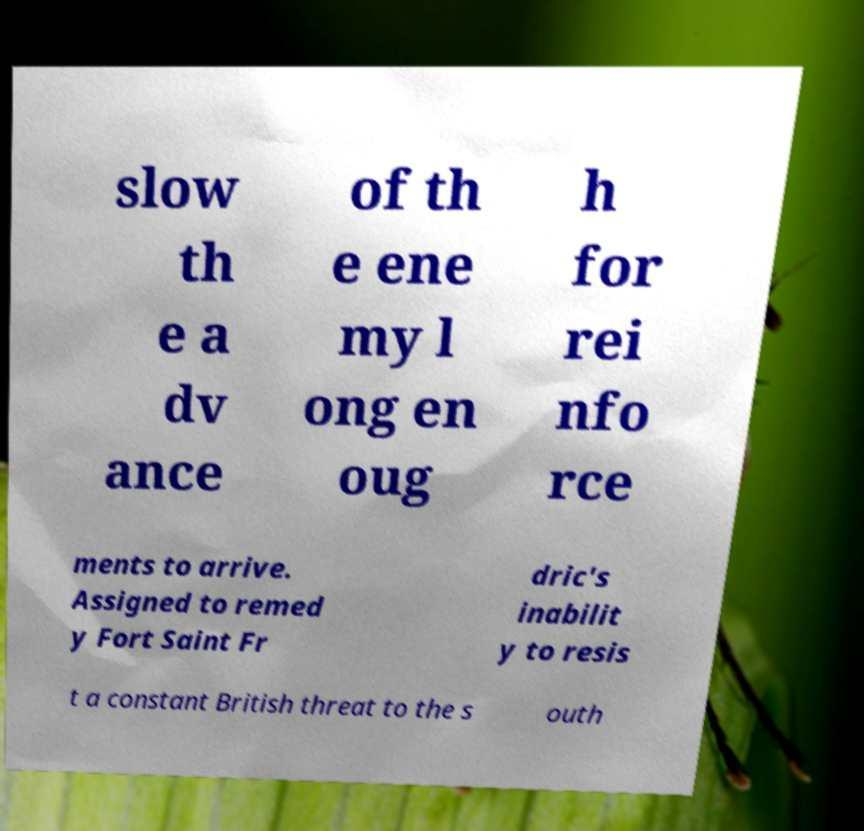I need the written content from this picture converted into text. Can you do that? slow th e a dv ance of th e ene my l ong en oug h for rei nfo rce ments to arrive. Assigned to remed y Fort Saint Fr dric's inabilit y to resis t a constant British threat to the s outh 